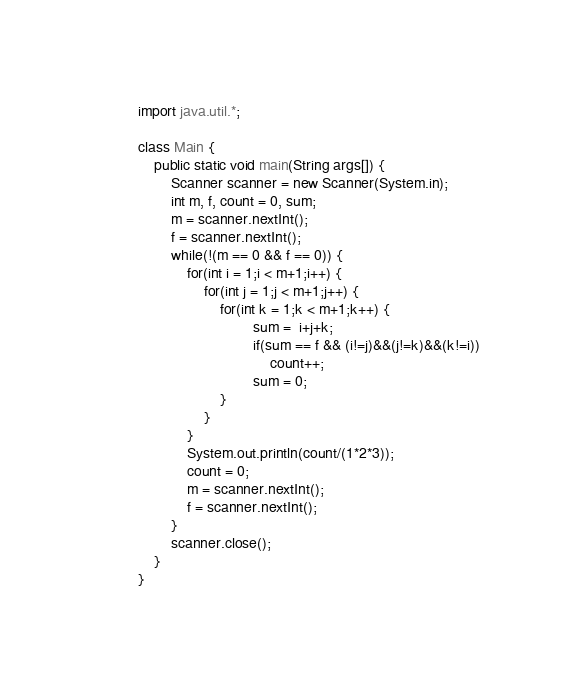<code> <loc_0><loc_0><loc_500><loc_500><_Java_>import java.util.*;

class Main {
	public static void main(String args[]) {
		Scanner scanner = new Scanner(System.in);
		int m, f, count = 0, sum;
		m = scanner.nextInt();
		f = scanner.nextInt();
		while(!(m == 0 && f == 0)) {
			for(int i = 1;i < m+1;i++) {
				for(int j = 1;j < m+1;j++) {
					for(int k = 1;k < m+1;k++) {
							sum =  i+j+k;
							if(sum == f && (i!=j)&&(j!=k)&&(k!=i)) 
								count++;
							sum = 0;
					}
				}
			}
			System.out.println(count/(1*2*3));
			count = 0;
			m = scanner.nextInt();
			f = scanner.nextInt();
		}
		scanner.close();
	}
}</code> 